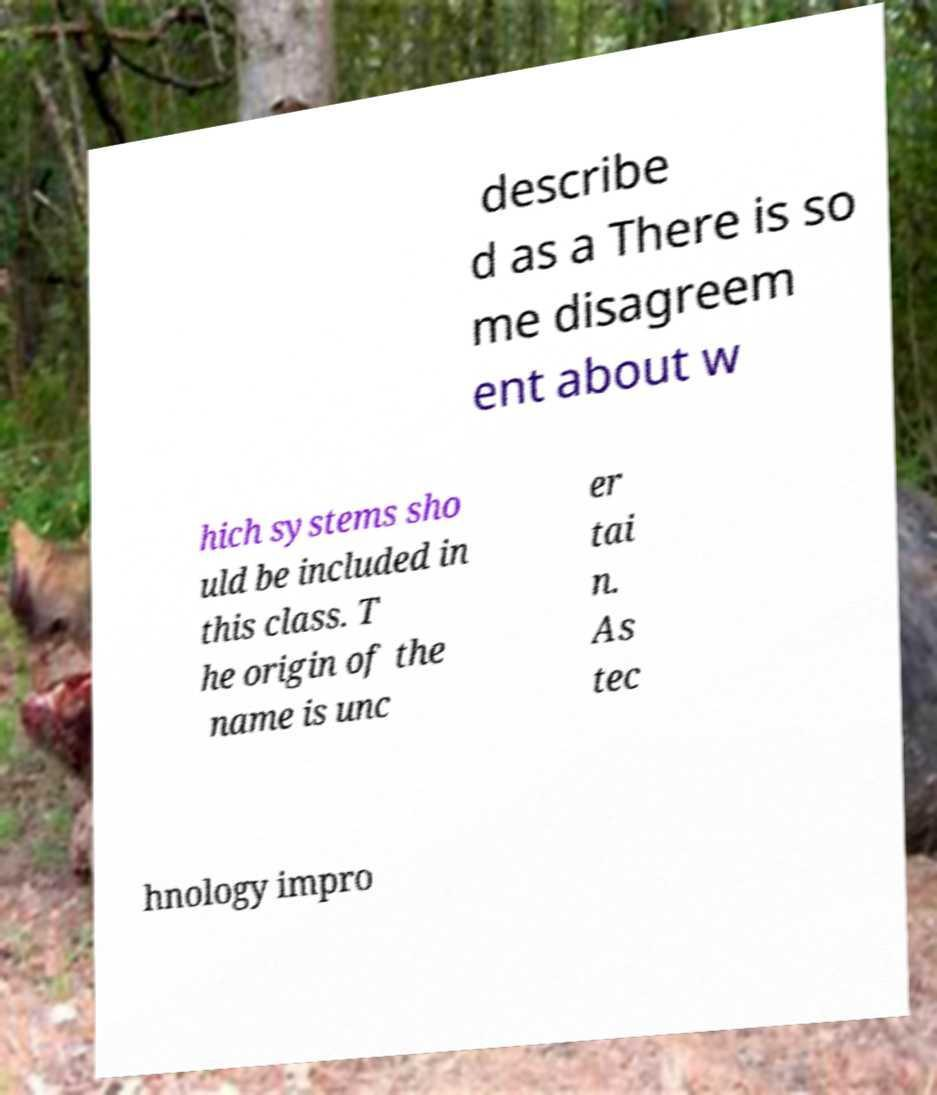Could you assist in decoding the text presented in this image and type it out clearly? describe d as a There is so me disagreem ent about w hich systems sho uld be included in this class. T he origin of the name is unc er tai n. As tec hnology impro 